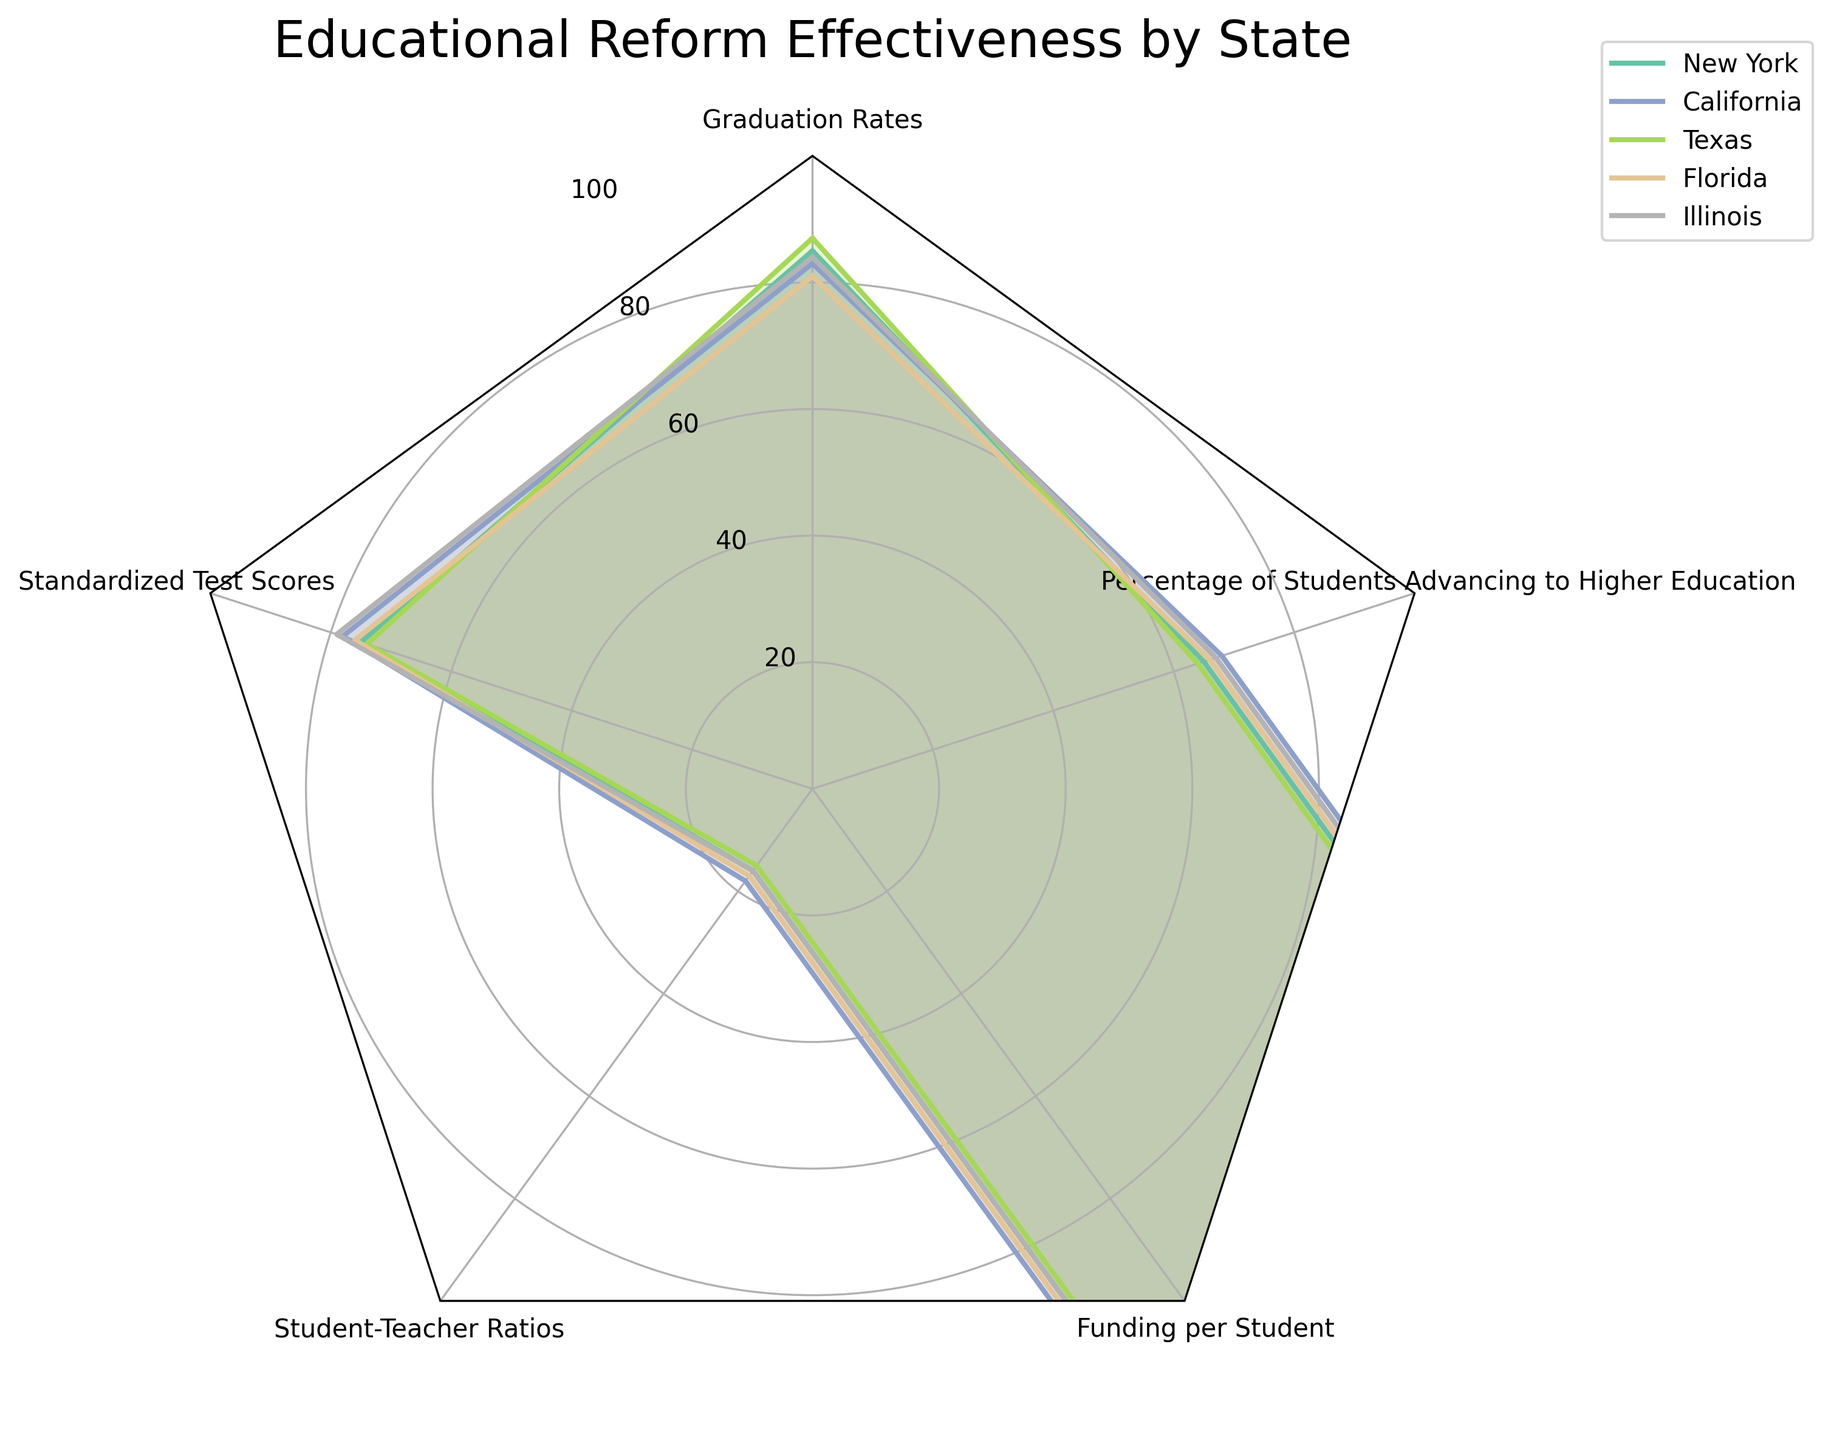what is the title of the figure? The title is usually at the top of the chart and provides a summary of what the figure is about. In this case, the title is "Educational Reform Effectiveness by State".
Answer: Educational Reform Effectiveness by State How many states are represented in the chart? Count the number of states listed in the figure, which are represented by different lines and colors. They are New York, California, Texas, Florida, and Illinois.
Answer: 5 Which category has the highest average value across all states? Calculate the average value for each category by summing the values and dividing by the number of states. Then compare the averages.
Answer: Graduation Rates Which state has the lowest score in Standardized Test Scores? Identify the value for Standardized Test Scores for each state and find the minimum. The states have scores of 75, 78, 74, 76, and 79. The lowest is Texas with 74.
Answer: Texas How does New York's Funding per Student compare to Florida’s? Look at the data for Funding per Student for New York and Florida. New York has $23,000 while Florida has $18,000. Compare these values.
Answer: New York's funding is higher What is the average percentage of students advancing to higher education for the states? Sum the percentage values for all states and then divide by the number of states. The percentages are 65, 68, 64, 66, and 67. The sum is 330, and the average is 330 / 5 = 66.
Answer: 66 Which state has the best overall performance in educational reforms? To determine the best overall performance, consider high values in Graduation Rates, Standardized Test Scores, and Percentage of Students Advancing to Higher Education, and low values in Student-Teacher Ratios. Calculate combined performance of each state in these areas.
Answer: Illinois Compare the Student-Teacher Ratios of all states. Which state performs the best in this category? Identify the values of Student-Teacher Ratios for each state: New York (16), California (18), Texas (15), Florida (17), and Illinois (16). Lower ratios are better.
Answer: Texas Which category shows the least variability in values across the states? Evaluate the range (difference between max and min values) for each category. The category with the smallest range has the least variability.
Answer: Percentage of Students Advancing to Higher Education Do higher funding levels per student correlate with better standardized test scores? Compare the Funding per Student and Standardized Test Scores across all states. Higher funding per student does not necessarily correlate with higher standardized test scores based on the observed data.
Answer: No 